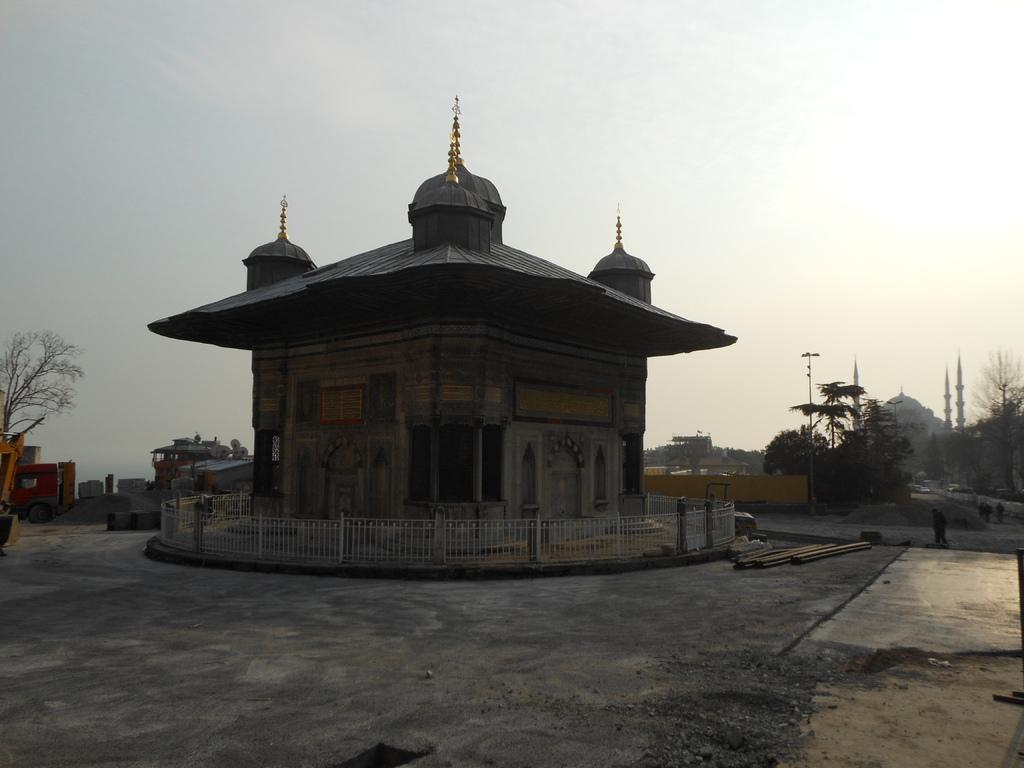What is the main structure in the image? There is a monument in the image. What type of barrier is present in the image? There is fencing in the image. What type of building can be seen in the background? There is a mosque visible in the background. What type of lighting is present in the background? There is a street light in the background. What type of vegetation is present in the background? There are trees in the background. What type of structures are present in the background? There are buildings in the background. What part of the natural environment is visible in the image? The sky is visible in the image. What type of weather condition can be inferred from the sky? Clouds are present in the sky, suggesting a partly cloudy day. What type of rose is being used to draw attention to the book in the image? There is no rose or book present in the image; it features a monument, fencing, and various background elements. 